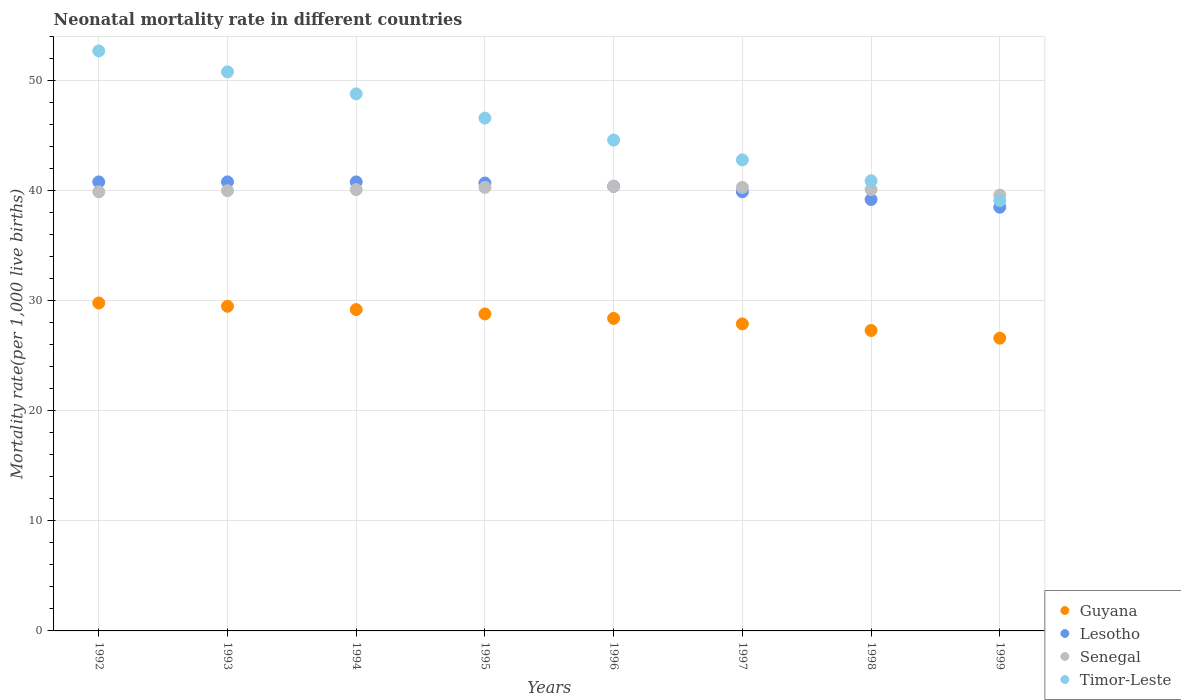How many different coloured dotlines are there?
Ensure brevity in your answer.  4. Is the number of dotlines equal to the number of legend labels?
Ensure brevity in your answer.  Yes. What is the neonatal mortality rate in Lesotho in 1993?
Offer a very short reply. 40.8. Across all years, what is the maximum neonatal mortality rate in Lesotho?
Your response must be concise. 40.8. Across all years, what is the minimum neonatal mortality rate in Guyana?
Make the answer very short. 26.6. In which year was the neonatal mortality rate in Lesotho minimum?
Keep it short and to the point. 1999. What is the total neonatal mortality rate in Lesotho in the graph?
Provide a succinct answer. 321.1. What is the difference between the neonatal mortality rate in Timor-Leste in 1996 and that in 1999?
Ensure brevity in your answer.  5.5. What is the difference between the neonatal mortality rate in Lesotho in 1995 and the neonatal mortality rate in Timor-Leste in 1996?
Keep it short and to the point. -3.9. What is the average neonatal mortality rate in Senegal per year?
Make the answer very short. 40.09. In the year 1995, what is the difference between the neonatal mortality rate in Timor-Leste and neonatal mortality rate in Lesotho?
Offer a very short reply. 5.9. In how many years, is the neonatal mortality rate in Timor-Leste greater than 44?
Your answer should be compact. 5. What is the ratio of the neonatal mortality rate in Guyana in 1993 to that in 1999?
Offer a very short reply. 1.11. Is the difference between the neonatal mortality rate in Timor-Leste in 1994 and 1995 greater than the difference between the neonatal mortality rate in Lesotho in 1994 and 1995?
Offer a terse response. Yes. What is the difference between the highest and the second highest neonatal mortality rate in Senegal?
Provide a succinct answer. 0.1. What is the difference between the highest and the lowest neonatal mortality rate in Timor-Leste?
Keep it short and to the point. 13.6. Is the sum of the neonatal mortality rate in Lesotho in 1993 and 1994 greater than the maximum neonatal mortality rate in Guyana across all years?
Offer a terse response. Yes. Is it the case that in every year, the sum of the neonatal mortality rate in Lesotho and neonatal mortality rate in Guyana  is greater than the neonatal mortality rate in Timor-Leste?
Keep it short and to the point. Yes. Does the neonatal mortality rate in Timor-Leste monotonically increase over the years?
Your answer should be very brief. No. Is the neonatal mortality rate in Timor-Leste strictly less than the neonatal mortality rate in Guyana over the years?
Your answer should be very brief. No. How many dotlines are there?
Keep it short and to the point. 4. How many years are there in the graph?
Keep it short and to the point. 8. What is the difference between two consecutive major ticks on the Y-axis?
Provide a short and direct response. 10. Are the values on the major ticks of Y-axis written in scientific E-notation?
Your response must be concise. No. Does the graph contain any zero values?
Your answer should be compact. No. What is the title of the graph?
Keep it short and to the point. Neonatal mortality rate in different countries. Does "San Marino" appear as one of the legend labels in the graph?
Provide a short and direct response. No. What is the label or title of the X-axis?
Your answer should be very brief. Years. What is the label or title of the Y-axis?
Offer a terse response. Mortality rate(per 1,0 live births). What is the Mortality rate(per 1,000 live births) in Guyana in 1992?
Your answer should be compact. 29.8. What is the Mortality rate(per 1,000 live births) of Lesotho in 1992?
Your response must be concise. 40.8. What is the Mortality rate(per 1,000 live births) in Senegal in 1992?
Provide a succinct answer. 39.9. What is the Mortality rate(per 1,000 live births) of Timor-Leste in 1992?
Offer a very short reply. 52.7. What is the Mortality rate(per 1,000 live births) in Guyana in 1993?
Give a very brief answer. 29.5. What is the Mortality rate(per 1,000 live births) of Lesotho in 1993?
Your response must be concise. 40.8. What is the Mortality rate(per 1,000 live births) in Senegal in 1993?
Your answer should be compact. 40. What is the Mortality rate(per 1,000 live births) in Timor-Leste in 1993?
Provide a short and direct response. 50.8. What is the Mortality rate(per 1,000 live births) in Guyana in 1994?
Offer a very short reply. 29.2. What is the Mortality rate(per 1,000 live births) in Lesotho in 1994?
Your answer should be compact. 40.8. What is the Mortality rate(per 1,000 live births) of Senegal in 1994?
Offer a terse response. 40.1. What is the Mortality rate(per 1,000 live births) in Timor-Leste in 1994?
Provide a succinct answer. 48.8. What is the Mortality rate(per 1,000 live births) in Guyana in 1995?
Offer a terse response. 28.8. What is the Mortality rate(per 1,000 live births) in Lesotho in 1995?
Offer a very short reply. 40.7. What is the Mortality rate(per 1,000 live births) of Senegal in 1995?
Your answer should be very brief. 40.3. What is the Mortality rate(per 1,000 live births) of Timor-Leste in 1995?
Offer a terse response. 46.6. What is the Mortality rate(per 1,000 live births) of Guyana in 1996?
Provide a short and direct response. 28.4. What is the Mortality rate(per 1,000 live births) in Lesotho in 1996?
Keep it short and to the point. 40.4. What is the Mortality rate(per 1,000 live births) in Senegal in 1996?
Offer a very short reply. 40.4. What is the Mortality rate(per 1,000 live births) of Timor-Leste in 1996?
Give a very brief answer. 44.6. What is the Mortality rate(per 1,000 live births) in Guyana in 1997?
Give a very brief answer. 27.9. What is the Mortality rate(per 1,000 live births) in Lesotho in 1997?
Your answer should be very brief. 39.9. What is the Mortality rate(per 1,000 live births) in Senegal in 1997?
Keep it short and to the point. 40.3. What is the Mortality rate(per 1,000 live births) of Timor-Leste in 1997?
Your response must be concise. 42.8. What is the Mortality rate(per 1,000 live births) in Guyana in 1998?
Your answer should be compact. 27.3. What is the Mortality rate(per 1,000 live births) in Lesotho in 1998?
Provide a short and direct response. 39.2. What is the Mortality rate(per 1,000 live births) of Senegal in 1998?
Offer a terse response. 40.1. What is the Mortality rate(per 1,000 live births) of Timor-Leste in 1998?
Ensure brevity in your answer.  40.9. What is the Mortality rate(per 1,000 live births) of Guyana in 1999?
Make the answer very short. 26.6. What is the Mortality rate(per 1,000 live births) in Lesotho in 1999?
Your answer should be compact. 38.5. What is the Mortality rate(per 1,000 live births) in Senegal in 1999?
Your response must be concise. 39.6. What is the Mortality rate(per 1,000 live births) of Timor-Leste in 1999?
Your answer should be compact. 39.1. Across all years, what is the maximum Mortality rate(per 1,000 live births) in Guyana?
Provide a short and direct response. 29.8. Across all years, what is the maximum Mortality rate(per 1,000 live births) of Lesotho?
Your answer should be very brief. 40.8. Across all years, what is the maximum Mortality rate(per 1,000 live births) of Senegal?
Ensure brevity in your answer.  40.4. Across all years, what is the maximum Mortality rate(per 1,000 live births) in Timor-Leste?
Give a very brief answer. 52.7. Across all years, what is the minimum Mortality rate(per 1,000 live births) in Guyana?
Your answer should be compact. 26.6. Across all years, what is the minimum Mortality rate(per 1,000 live births) of Lesotho?
Provide a short and direct response. 38.5. Across all years, what is the minimum Mortality rate(per 1,000 live births) of Senegal?
Provide a short and direct response. 39.6. Across all years, what is the minimum Mortality rate(per 1,000 live births) in Timor-Leste?
Offer a very short reply. 39.1. What is the total Mortality rate(per 1,000 live births) of Guyana in the graph?
Offer a very short reply. 227.5. What is the total Mortality rate(per 1,000 live births) in Lesotho in the graph?
Ensure brevity in your answer.  321.1. What is the total Mortality rate(per 1,000 live births) in Senegal in the graph?
Your response must be concise. 320.7. What is the total Mortality rate(per 1,000 live births) in Timor-Leste in the graph?
Keep it short and to the point. 366.3. What is the difference between the Mortality rate(per 1,000 live births) of Guyana in 1992 and that in 1993?
Your response must be concise. 0.3. What is the difference between the Mortality rate(per 1,000 live births) in Timor-Leste in 1992 and that in 1993?
Provide a succinct answer. 1.9. What is the difference between the Mortality rate(per 1,000 live births) of Lesotho in 1992 and that in 1994?
Offer a very short reply. 0. What is the difference between the Mortality rate(per 1,000 live births) in Senegal in 1992 and that in 1994?
Make the answer very short. -0.2. What is the difference between the Mortality rate(per 1,000 live births) in Timor-Leste in 1992 and that in 1994?
Offer a very short reply. 3.9. What is the difference between the Mortality rate(per 1,000 live births) of Lesotho in 1992 and that in 1995?
Provide a succinct answer. 0.1. What is the difference between the Mortality rate(per 1,000 live births) of Timor-Leste in 1992 and that in 1995?
Keep it short and to the point. 6.1. What is the difference between the Mortality rate(per 1,000 live births) of Guyana in 1992 and that in 1996?
Your answer should be very brief. 1.4. What is the difference between the Mortality rate(per 1,000 live births) of Senegal in 1992 and that in 1996?
Offer a very short reply. -0.5. What is the difference between the Mortality rate(per 1,000 live births) of Timor-Leste in 1992 and that in 1996?
Your answer should be very brief. 8.1. What is the difference between the Mortality rate(per 1,000 live births) of Lesotho in 1992 and that in 1997?
Provide a succinct answer. 0.9. What is the difference between the Mortality rate(per 1,000 live births) in Senegal in 1992 and that in 1997?
Ensure brevity in your answer.  -0.4. What is the difference between the Mortality rate(per 1,000 live births) of Guyana in 1992 and that in 1999?
Your response must be concise. 3.2. What is the difference between the Mortality rate(per 1,000 live births) in Lesotho in 1992 and that in 1999?
Keep it short and to the point. 2.3. What is the difference between the Mortality rate(per 1,000 live births) in Senegal in 1992 and that in 1999?
Your answer should be very brief. 0.3. What is the difference between the Mortality rate(per 1,000 live births) in Guyana in 1993 and that in 1994?
Offer a terse response. 0.3. What is the difference between the Mortality rate(per 1,000 live births) in Timor-Leste in 1993 and that in 1994?
Offer a very short reply. 2. What is the difference between the Mortality rate(per 1,000 live births) in Lesotho in 1993 and that in 1995?
Offer a terse response. 0.1. What is the difference between the Mortality rate(per 1,000 live births) of Senegal in 1993 and that in 1995?
Offer a terse response. -0.3. What is the difference between the Mortality rate(per 1,000 live births) of Timor-Leste in 1993 and that in 1995?
Offer a terse response. 4.2. What is the difference between the Mortality rate(per 1,000 live births) of Guyana in 1993 and that in 1996?
Give a very brief answer. 1.1. What is the difference between the Mortality rate(per 1,000 live births) of Lesotho in 1993 and that in 1996?
Provide a succinct answer. 0.4. What is the difference between the Mortality rate(per 1,000 live births) of Guyana in 1993 and that in 1997?
Offer a very short reply. 1.6. What is the difference between the Mortality rate(per 1,000 live births) of Lesotho in 1993 and that in 1998?
Ensure brevity in your answer.  1.6. What is the difference between the Mortality rate(per 1,000 live births) of Timor-Leste in 1993 and that in 1998?
Offer a very short reply. 9.9. What is the difference between the Mortality rate(per 1,000 live births) of Lesotho in 1993 and that in 1999?
Give a very brief answer. 2.3. What is the difference between the Mortality rate(per 1,000 live births) of Senegal in 1993 and that in 1999?
Offer a terse response. 0.4. What is the difference between the Mortality rate(per 1,000 live births) in Senegal in 1994 and that in 1995?
Make the answer very short. -0.2. What is the difference between the Mortality rate(per 1,000 live births) of Senegal in 1994 and that in 1996?
Provide a short and direct response. -0.3. What is the difference between the Mortality rate(per 1,000 live births) in Timor-Leste in 1994 and that in 1996?
Give a very brief answer. 4.2. What is the difference between the Mortality rate(per 1,000 live births) of Lesotho in 1994 and that in 1997?
Ensure brevity in your answer.  0.9. What is the difference between the Mortality rate(per 1,000 live births) of Senegal in 1994 and that in 1997?
Your answer should be compact. -0.2. What is the difference between the Mortality rate(per 1,000 live births) in Guyana in 1994 and that in 1998?
Your answer should be very brief. 1.9. What is the difference between the Mortality rate(per 1,000 live births) of Lesotho in 1994 and that in 1998?
Provide a short and direct response. 1.6. What is the difference between the Mortality rate(per 1,000 live births) of Timor-Leste in 1994 and that in 1998?
Provide a short and direct response. 7.9. What is the difference between the Mortality rate(per 1,000 live births) of Senegal in 1994 and that in 1999?
Ensure brevity in your answer.  0.5. What is the difference between the Mortality rate(per 1,000 live births) of Timor-Leste in 1994 and that in 1999?
Offer a terse response. 9.7. What is the difference between the Mortality rate(per 1,000 live births) of Guyana in 1995 and that in 1996?
Give a very brief answer. 0.4. What is the difference between the Mortality rate(per 1,000 live births) in Lesotho in 1995 and that in 1996?
Keep it short and to the point. 0.3. What is the difference between the Mortality rate(per 1,000 live births) in Timor-Leste in 1995 and that in 1997?
Your answer should be compact. 3.8. What is the difference between the Mortality rate(per 1,000 live births) of Guyana in 1995 and that in 1999?
Give a very brief answer. 2.2. What is the difference between the Mortality rate(per 1,000 live births) in Lesotho in 1995 and that in 1999?
Provide a short and direct response. 2.2. What is the difference between the Mortality rate(per 1,000 live births) of Timor-Leste in 1995 and that in 1999?
Your answer should be compact. 7.5. What is the difference between the Mortality rate(per 1,000 live births) in Senegal in 1996 and that in 1997?
Give a very brief answer. 0.1. What is the difference between the Mortality rate(per 1,000 live births) in Timor-Leste in 1996 and that in 1997?
Provide a short and direct response. 1.8. What is the difference between the Mortality rate(per 1,000 live births) of Guyana in 1996 and that in 1998?
Offer a very short reply. 1.1. What is the difference between the Mortality rate(per 1,000 live births) in Lesotho in 1996 and that in 1998?
Offer a terse response. 1.2. What is the difference between the Mortality rate(per 1,000 live births) in Senegal in 1996 and that in 1998?
Keep it short and to the point. 0.3. What is the difference between the Mortality rate(per 1,000 live births) in Guyana in 1996 and that in 1999?
Ensure brevity in your answer.  1.8. What is the difference between the Mortality rate(per 1,000 live births) in Lesotho in 1996 and that in 1999?
Keep it short and to the point. 1.9. What is the difference between the Mortality rate(per 1,000 live births) of Senegal in 1996 and that in 1999?
Your answer should be compact. 0.8. What is the difference between the Mortality rate(per 1,000 live births) in Timor-Leste in 1996 and that in 1999?
Keep it short and to the point. 5.5. What is the difference between the Mortality rate(per 1,000 live births) of Lesotho in 1997 and that in 1998?
Give a very brief answer. 0.7. What is the difference between the Mortality rate(per 1,000 live births) in Senegal in 1997 and that in 1998?
Keep it short and to the point. 0.2. What is the difference between the Mortality rate(per 1,000 live births) of Timor-Leste in 1997 and that in 1998?
Your response must be concise. 1.9. What is the difference between the Mortality rate(per 1,000 live births) of Lesotho in 1997 and that in 1999?
Your answer should be compact. 1.4. What is the difference between the Mortality rate(per 1,000 live births) in Timor-Leste in 1997 and that in 1999?
Your response must be concise. 3.7. What is the difference between the Mortality rate(per 1,000 live births) in Lesotho in 1998 and that in 1999?
Your response must be concise. 0.7. What is the difference between the Mortality rate(per 1,000 live births) in Senegal in 1998 and that in 1999?
Give a very brief answer. 0.5. What is the difference between the Mortality rate(per 1,000 live births) in Guyana in 1992 and the Mortality rate(per 1,000 live births) in Timor-Leste in 1993?
Give a very brief answer. -21. What is the difference between the Mortality rate(per 1,000 live births) of Lesotho in 1992 and the Mortality rate(per 1,000 live births) of Timor-Leste in 1993?
Make the answer very short. -10. What is the difference between the Mortality rate(per 1,000 live births) of Senegal in 1992 and the Mortality rate(per 1,000 live births) of Timor-Leste in 1993?
Offer a very short reply. -10.9. What is the difference between the Mortality rate(per 1,000 live births) in Guyana in 1992 and the Mortality rate(per 1,000 live births) in Senegal in 1994?
Offer a terse response. -10.3. What is the difference between the Mortality rate(per 1,000 live births) in Senegal in 1992 and the Mortality rate(per 1,000 live births) in Timor-Leste in 1994?
Provide a succinct answer. -8.9. What is the difference between the Mortality rate(per 1,000 live births) in Guyana in 1992 and the Mortality rate(per 1,000 live births) in Timor-Leste in 1995?
Offer a terse response. -16.8. What is the difference between the Mortality rate(per 1,000 live births) of Senegal in 1992 and the Mortality rate(per 1,000 live births) of Timor-Leste in 1995?
Ensure brevity in your answer.  -6.7. What is the difference between the Mortality rate(per 1,000 live births) in Guyana in 1992 and the Mortality rate(per 1,000 live births) in Lesotho in 1996?
Provide a succinct answer. -10.6. What is the difference between the Mortality rate(per 1,000 live births) in Guyana in 1992 and the Mortality rate(per 1,000 live births) in Timor-Leste in 1996?
Provide a succinct answer. -14.8. What is the difference between the Mortality rate(per 1,000 live births) of Lesotho in 1992 and the Mortality rate(per 1,000 live births) of Senegal in 1996?
Provide a short and direct response. 0.4. What is the difference between the Mortality rate(per 1,000 live births) of Lesotho in 1992 and the Mortality rate(per 1,000 live births) of Timor-Leste in 1996?
Your answer should be compact. -3.8. What is the difference between the Mortality rate(per 1,000 live births) in Senegal in 1992 and the Mortality rate(per 1,000 live births) in Timor-Leste in 1996?
Offer a very short reply. -4.7. What is the difference between the Mortality rate(per 1,000 live births) of Guyana in 1992 and the Mortality rate(per 1,000 live births) of Senegal in 1997?
Your answer should be compact. -10.5. What is the difference between the Mortality rate(per 1,000 live births) of Guyana in 1992 and the Mortality rate(per 1,000 live births) of Timor-Leste in 1997?
Your answer should be compact. -13. What is the difference between the Mortality rate(per 1,000 live births) in Guyana in 1992 and the Mortality rate(per 1,000 live births) in Lesotho in 1998?
Give a very brief answer. -9.4. What is the difference between the Mortality rate(per 1,000 live births) of Lesotho in 1992 and the Mortality rate(per 1,000 live births) of Timor-Leste in 1998?
Keep it short and to the point. -0.1. What is the difference between the Mortality rate(per 1,000 live births) of Senegal in 1992 and the Mortality rate(per 1,000 live births) of Timor-Leste in 1998?
Provide a short and direct response. -1. What is the difference between the Mortality rate(per 1,000 live births) of Guyana in 1992 and the Mortality rate(per 1,000 live births) of Senegal in 1999?
Your response must be concise. -9.8. What is the difference between the Mortality rate(per 1,000 live births) of Guyana in 1992 and the Mortality rate(per 1,000 live births) of Timor-Leste in 1999?
Your answer should be compact. -9.3. What is the difference between the Mortality rate(per 1,000 live births) in Lesotho in 1992 and the Mortality rate(per 1,000 live births) in Senegal in 1999?
Keep it short and to the point. 1.2. What is the difference between the Mortality rate(per 1,000 live births) of Guyana in 1993 and the Mortality rate(per 1,000 live births) of Lesotho in 1994?
Your response must be concise. -11.3. What is the difference between the Mortality rate(per 1,000 live births) in Guyana in 1993 and the Mortality rate(per 1,000 live births) in Timor-Leste in 1994?
Keep it short and to the point. -19.3. What is the difference between the Mortality rate(per 1,000 live births) in Lesotho in 1993 and the Mortality rate(per 1,000 live births) in Senegal in 1994?
Your answer should be compact. 0.7. What is the difference between the Mortality rate(per 1,000 live births) of Guyana in 1993 and the Mortality rate(per 1,000 live births) of Lesotho in 1995?
Give a very brief answer. -11.2. What is the difference between the Mortality rate(per 1,000 live births) of Guyana in 1993 and the Mortality rate(per 1,000 live births) of Senegal in 1995?
Ensure brevity in your answer.  -10.8. What is the difference between the Mortality rate(per 1,000 live births) in Guyana in 1993 and the Mortality rate(per 1,000 live births) in Timor-Leste in 1995?
Offer a very short reply. -17.1. What is the difference between the Mortality rate(per 1,000 live births) in Lesotho in 1993 and the Mortality rate(per 1,000 live births) in Timor-Leste in 1995?
Your answer should be compact. -5.8. What is the difference between the Mortality rate(per 1,000 live births) of Senegal in 1993 and the Mortality rate(per 1,000 live births) of Timor-Leste in 1995?
Your answer should be very brief. -6.6. What is the difference between the Mortality rate(per 1,000 live births) in Guyana in 1993 and the Mortality rate(per 1,000 live births) in Lesotho in 1996?
Your response must be concise. -10.9. What is the difference between the Mortality rate(per 1,000 live births) in Guyana in 1993 and the Mortality rate(per 1,000 live births) in Timor-Leste in 1996?
Your response must be concise. -15.1. What is the difference between the Mortality rate(per 1,000 live births) in Lesotho in 1993 and the Mortality rate(per 1,000 live births) in Senegal in 1996?
Give a very brief answer. 0.4. What is the difference between the Mortality rate(per 1,000 live births) in Guyana in 1993 and the Mortality rate(per 1,000 live births) in Lesotho in 1997?
Your answer should be compact. -10.4. What is the difference between the Mortality rate(per 1,000 live births) in Guyana in 1993 and the Mortality rate(per 1,000 live births) in Senegal in 1997?
Your answer should be very brief. -10.8. What is the difference between the Mortality rate(per 1,000 live births) in Guyana in 1993 and the Mortality rate(per 1,000 live births) in Timor-Leste in 1997?
Give a very brief answer. -13.3. What is the difference between the Mortality rate(per 1,000 live births) of Senegal in 1993 and the Mortality rate(per 1,000 live births) of Timor-Leste in 1997?
Offer a very short reply. -2.8. What is the difference between the Mortality rate(per 1,000 live births) of Guyana in 1993 and the Mortality rate(per 1,000 live births) of Lesotho in 1998?
Ensure brevity in your answer.  -9.7. What is the difference between the Mortality rate(per 1,000 live births) of Guyana in 1993 and the Mortality rate(per 1,000 live births) of Timor-Leste in 1998?
Offer a terse response. -11.4. What is the difference between the Mortality rate(per 1,000 live births) in Lesotho in 1993 and the Mortality rate(per 1,000 live births) in Timor-Leste in 1998?
Keep it short and to the point. -0.1. What is the difference between the Mortality rate(per 1,000 live births) of Senegal in 1993 and the Mortality rate(per 1,000 live births) of Timor-Leste in 1998?
Provide a short and direct response. -0.9. What is the difference between the Mortality rate(per 1,000 live births) of Guyana in 1993 and the Mortality rate(per 1,000 live births) of Lesotho in 1999?
Ensure brevity in your answer.  -9. What is the difference between the Mortality rate(per 1,000 live births) of Guyana in 1993 and the Mortality rate(per 1,000 live births) of Senegal in 1999?
Offer a very short reply. -10.1. What is the difference between the Mortality rate(per 1,000 live births) in Guyana in 1993 and the Mortality rate(per 1,000 live births) in Timor-Leste in 1999?
Your answer should be compact. -9.6. What is the difference between the Mortality rate(per 1,000 live births) in Lesotho in 1993 and the Mortality rate(per 1,000 live births) in Senegal in 1999?
Your answer should be compact. 1.2. What is the difference between the Mortality rate(per 1,000 live births) of Lesotho in 1993 and the Mortality rate(per 1,000 live births) of Timor-Leste in 1999?
Give a very brief answer. 1.7. What is the difference between the Mortality rate(per 1,000 live births) of Senegal in 1993 and the Mortality rate(per 1,000 live births) of Timor-Leste in 1999?
Your answer should be compact. 0.9. What is the difference between the Mortality rate(per 1,000 live births) of Guyana in 1994 and the Mortality rate(per 1,000 live births) of Timor-Leste in 1995?
Provide a succinct answer. -17.4. What is the difference between the Mortality rate(per 1,000 live births) in Lesotho in 1994 and the Mortality rate(per 1,000 live births) in Senegal in 1995?
Your answer should be compact. 0.5. What is the difference between the Mortality rate(per 1,000 live births) in Guyana in 1994 and the Mortality rate(per 1,000 live births) in Lesotho in 1996?
Your response must be concise. -11.2. What is the difference between the Mortality rate(per 1,000 live births) in Guyana in 1994 and the Mortality rate(per 1,000 live births) in Timor-Leste in 1996?
Ensure brevity in your answer.  -15.4. What is the difference between the Mortality rate(per 1,000 live births) of Lesotho in 1994 and the Mortality rate(per 1,000 live births) of Senegal in 1996?
Make the answer very short. 0.4. What is the difference between the Mortality rate(per 1,000 live births) in Senegal in 1994 and the Mortality rate(per 1,000 live births) in Timor-Leste in 1996?
Your response must be concise. -4.5. What is the difference between the Mortality rate(per 1,000 live births) in Guyana in 1994 and the Mortality rate(per 1,000 live births) in Lesotho in 1998?
Offer a very short reply. -10. What is the difference between the Mortality rate(per 1,000 live births) in Guyana in 1994 and the Mortality rate(per 1,000 live births) in Senegal in 1998?
Your answer should be very brief. -10.9. What is the difference between the Mortality rate(per 1,000 live births) in Lesotho in 1994 and the Mortality rate(per 1,000 live births) in Senegal in 1998?
Offer a very short reply. 0.7. What is the difference between the Mortality rate(per 1,000 live births) of Guyana in 1994 and the Mortality rate(per 1,000 live births) of Senegal in 1999?
Give a very brief answer. -10.4. What is the difference between the Mortality rate(per 1,000 live births) of Guyana in 1994 and the Mortality rate(per 1,000 live births) of Timor-Leste in 1999?
Keep it short and to the point. -9.9. What is the difference between the Mortality rate(per 1,000 live births) in Lesotho in 1994 and the Mortality rate(per 1,000 live births) in Senegal in 1999?
Your answer should be very brief. 1.2. What is the difference between the Mortality rate(per 1,000 live births) of Lesotho in 1994 and the Mortality rate(per 1,000 live births) of Timor-Leste in 1999?
Your answer should be very brief. 1.7. What is the difference between the Mortality rate(per 1,000 live births) in Senegal in 1994 and the Mortality rate(per 1,000 live births) in Timor-Leste in 1999?
Offer a very short reply. 1. What is the difference between the Mortality rate(per 1,000 live births) in Guyana in 1995 and the Mortality rate(per 1,000 live births) in Timor-Leste in 1996?
Give a very brief answer. -15.8. What is the difference between the Mortality rate(per 1,000 live births) in Lesotho in 1995 and the Mortality rate(per 1,000 live births) in Timor-Leste in 1996?
Offer a terse response. -3.9. What is the difference between the Mortality rate(per 1,000 live births) of Senegal in 1995 and the Mortality rate(per 1,000 live births) of Timor-Leste in 1996?
Your answer should be very brief. -4.3. What is the difference between the Mortality rate(per 1,000 live births) in Guyana in 1995 and the Mortality rate(per 1,000 live births) in Lesotho in 1997?
Your answer should be very brief. -11.1. What is the difference between the Mortality rate(per 1,000 live births) in Guyana in 1995 and the Mortality rate(per 1,000 live births) in Timor-Leste in 1997?
Give a very brief answer. -14. What is the difference between the Mortality rate(per 1,000 live births) of Lesotho in 1995 and the Mortality rate(per 1,000 live births) of Senegal in 1997?
Provide a short and direct response. 0.4. What is the difference between the Mortality rate(per 1,000 live births) of Lesotho in 1995 and the Mortality rate(per 1,000 live births) of Timor-Leste in 1997?
Your answer should be compact. -2.1. What is the difference between the Mortality rate(per 1,000 live births) of Guyana in 1995 and the Mortality rate(per 1,000 live births) of Senegal in 1998?
Ensure brevity in your answer.  -11.3. What is the difference between the Mortality rate(per 1,000 live births) in Guyana in 1995 and the Mortality rate(per 1,000 live births) in Senegal in 1999?
Make the answer very short. -10.8. What is the difference between the Mortality rate(per 1,000 live births) of Lesotho in 1995 and the Mortality rate(per 1,000 live births) of Timor-Leste in 1999?
Ensure brevity in your answer.  1.6. What is the difference between the Mortality rate(per 1,000 live births) in Guyana in 1996 and the Mortality rate(per 1,000 live births) in Lesotho in 1997?
Your answer should be compact. -11.5. What is the difference between the Mortality rate(per 1,000 live births) of Guyana in 1996 and the Mortality rate(per 1,000 live births) of Senegal in 1997?
Ensure brevity in your answer.  -11.9. What is the difference between the Mortality rate(per 1,000 live births) in Guyana in 1996 and the Mortality rate(per 1,000 live births) in Timor-Leste in 1997?
Give a very brief answer. -14.4. What is the difference between the Mortality rate(per 1,000 live births) of Lesotho in 1996 and the Mortality rate(per 1,000 live births) of Senegal in 1997?
Provide a succinct answer. 0.1. What is the difference between the Mortality rate(per 1,000 live births) in Lesotho in 1996 and the Mortality rate(per 1,000 live births) in Timor-Leste in 1997?
Provide a succinct answer. -2.4. What is the difference between the Mortality rate(per 1,000 live births) in Senegal in 1996 and the Mortality rate(per 1,000 live births) in Timor-Leste in 1997?
Your answer should be compact. -2.4. What is the difference between the Mortality rate(per 1,000 live births) in Guyana in 1996 and the Mortality rate(per 1,000 live births) in Senegal in 1998?
Your answer should be compact. -11.7. What is the difference between the Mortality rate(per 1,000 live births) of Lesotho in 1996 and the Mortality rate(per 1,000 live births) of Senegal in 1998?
Offer a terse response. 0.3. What is the difference between the Mortality rate(per 1,000 live births) in Lesotho in 1996 and the Mortality rate(per 1,000 live births) in Timor-Leste in 1998?
Keep it short and to the point. -0.5. What is the difference between the Mortality rate(per 1,000 live births) of Lesotho in 1996 and the Mortality rate(per 1,000 live births) of Senegal in 1999?
Your response must be concise. 0.8. What is the difference between the Mortality rate(per 1,000 live births) in Lesotho in 1996 and the Mortality rate(per 1,000 live births) in Timor-Leste in 1999?
Give a very brief answer. 1.3. What is the difference between the Mortality rate(per 1,000 live births) in Guyana in 1997 and the Mortality rate(per 1,000 live births) in Lesotho in 1998?
Your answer should be very brief. -11.3. What is the difference between the Mortality rate(per 1,000 live births) in Guyana in 1997 and the Mortality rate(per 1,000 live births) in Timor-Leste in 1998?
Your answer should be very brief. -13. What is the difference between the Mortality rate(per 1,000 live births) in Lesotho in 1997 and the Mortality rate(per 1,000 live births) in Senegal in 1998?
Your answer should be very brief. -0.2. What is the difference between the Mortality rate(per 1,000 live births) of Senegal in 1997 and the Mortality rate(per 1,000 live births) of Timor-Leste in 1998?
Ensure brevity in your answer.  -0.6. What is the difference between the Mortality rate(per 1,000 live births) in Guyana in 1997 and the Mortality rate(per 1,000 live births) in Senegal in 1999?
Give a very brief answer. -11.7. What is the difference between the Mortality rate(per 1,000 live births) in Guyana in 1997 and the Mortality rate(per 1,000 live births) in Timor-Leste in 1999?
Provide a short and direct response. -11.2. What is the difference between the Mortality rate(per 1,000 live births) in Lesotho in 1997 and the Mortality rate(per 1,000 live births) in Senegal in 1999?
Provide a short and direct response. 0.3. What is the difference between the Mortality rate(per 1,000 live births) in Lesotho in 1997 and the Mortality rate(per 1,000 live births) in Timor-Leste in 1999?
Make the answer very short. 0.8. What is the difference between the Mortality rate(per 1,000 live births) in Guyana in 1998 and the Mortality rate(per 1,000 live births) in Lesotho in 1999?
Keep it short and to the point. -11.2. What is the difference between the Mortality rate(per 1,000 live births) in Guyana in 1998 and the Mortality rate(per 1,000 live births) in Timor-Leste in 1999?
Offer a very short reply. -11.8. What is the difference between the Mortality rate(per 1,000 live births) of Lesotho in 1998 and the Mortality rate(per 1,000 live births) of Senegal in 1999?
Give a very brief answer. -0.4. What is the difference between the Mortality rate(per 1,000 live births) in Lesotho in 1998 and the Mortality rate(per 1,000 live births) in Timor-Leste in 1999?
Your answer should be compact. 0.1. What is the difference between the Mortality rate(per 1,000 live births) of Senegal in 1998 and the Mortality rate(per 1,000 live births) of Timor-Leste in 1999?
Your response must be concise. 1. What is the average Mortality rate(per 1,000 live births) of Guyana per year?
Keep it short and to the point. 28.44. What is the average Mortality rate(per 1,000 live births) in Lesotho per year?
Your answer should be very brief. 40.14. What is the average Mortality rate(per 1,000 live births) in Senegal per year?
Provide a succinct answer. 40.09. What is the average Mortality rate(per 1,000 live births) in Timor-Leste per year?
Keep it short and to the point. 45.79. In the year 1992, what is the difference between the Mortality rate(per 1,000 live births) in Guyana and Mortality rate(per 1,000 live births) in Timor-Leste?
Offer a terse response. -22.9. In the year 1992, what is the difference between the Mortality rate(per 1,000 live births) of Lesotho and Mortality rate(per 1,000 live births) of Senegal?
Give a very brief answer. 0.9. In the year 1992, what is the difference between the Mortality rate(per 1,000 live births) in Lesotho and Mortality rate(per 1,000 live births) in Timor-Leste?
Keep it short and to the point. -11.9. In the year 1993, what is the difference between the Mortality rate(per 1,000 live births) of Guyana and Mortality rate(per 1,000 live births) of Timor-Leste?
Offer a terse response. -21.3. In the year 1993, what is the difference between the Mortality rate(per 1,000 live births) in Lesotho and Mortality rate(per 1,000 live births) in Senegal?
Your answer should be very brief. 0.8. In the year 1993, what is the difference between the Mortality rate(per 1,000 live births) in Lesotho and Mortality rate(per 1,000 live births) in Timor-Leste?
Make the answer very short. -10. In the year 1993, what is the difference between the Mortality rate(per 1,000 live births) of Senegal and Mortality rate(per 1,000 live births) of Timor-Leste?
Provide a succinct answer. -10.8. In the year 1994, what is the difference between the Mortality rate(per 1,000 live births) of Guyana and Mortality rate(per 1,000 live births) of Lesotho?
Keep it short and to the point. -11.6. In the year 1994, what is the difference between the Mortality rate(per 1,000 live births) in Guyana and Mortality rate(per 1,000 live births) in Senegal?
Offer a very short reply. -10.9. In the year 1994, what is the difference between the Mortality rate(per 1,000 live births) in Guyana and Mortality rate(per 1,000 live births) in Timor-Leste?
Provide a short and direct response. -19.6. In the year 1994, what is the difference between the Mortality rate(per 1,000 live births) of Lesotho and Mortality rate(per 1,000 live births) of Timor-Leste?
Offer a terse response. -8. In the year 1995, what is the difference between the Mortality rate(per 1,000 live births) of Guyana and Mortality rate(per 1,000 live births) of Timor-Leste?
Offer a very short reply. -17.8. In the year 1995, what is the difference between the Mortality rate(per 1,000 live births) in Senegal and Mortality rate(per 1,000 live births) in Timor-Leste?
Provide a succinct answer. -6.3. In the year 1996, what is the difference between the Mortality rate(per 1,000 live births) of Guyana and Mortality rate(per 1,000 live births) of Senegal?
Provide a succinct answer. -12. In the year 1996, what is the difference between the Mortality rate(per 1,000 live births) in Guyana and Mortality rate(per 1,000 live births) in Timor-Leste?
Provide a short and direct response. -16.2. In the year 1996, what is the difference between the Mortality rate(per 1,000 live births) of Senegal and Mortality rate(per 1,000 live births) of Timor-Leste?
Your answer should be compact. -4.2. In the year 1997, what is the difference between the Mortality rate(per 1,000 live births) in Guyana and Mortality rate(per 1,000 live births) in Senegal?
Your answer should be very brief. -12.4. In the year 1997, what is the difference between the Mortality rate(per 1,000 live births) in Guyana and Mortality rate(per 1,000 live births) in Timor-Leste?
Give a very brief answer. -14.9. In the year 1997, what is the difference between the Mortality rate(per 1,000 live births) of Lesotho and Mortality rate(per 1,000 live births) of Senegal?
Your response must be concise. -0.4. In the year 1997, what is the difference between the Mortality rate(per 1,000 live births) in Senegal and Mortality rate(per 1,000 live births) in Timor-Leste?
Offer a terse response. -2.5. In the year 1998, what is the difference between the Mortality rate(per 1,000 live births) in Guyana and Mortality rate(per 1,000 live births) in Lesotho?
Ensure brevity in your answer.  -11.9. In the year 1998, what is the difference between the Mortality rate(per 1,000 live births) in Guyana and Mortality rate(per 1,000 live births) in Senegal?
Your answer should be very brief. -12.8. In the year 1998, what is the difference between the Mortality rate(per 1,000 live births) of Lesotho and Mortality rate(per 1,000 live births) of Senegal?
Offer a very short reply. -0.9. In the year 1999, what is the difference between the Mortality rate(per 1,000 live births) of Guyana and Mortality rate(per 1,000 live births) of Senegal?
Give a very brief answer. -13. In the year 1999, what is the difference between the Mortality rate(per 1,000 live births) in Lesotho and Mortality rate(per 1,000 live births) in Senegal?
Offer a terse response. -1.1. What is the ratio of the Mortality rate(per 1,000 live births) of Guyana in 1992 to that in 1993?
Provide a short and direct response. 1.01. What is the ratio of the Mortality rate(per 1,000 live births) in Timor-Leste in 1992 to that in 1993?
Provide a succinct answer. 1.04. What is the ratio of the Mortality rate(per 1,000 live births) in Guyana in 1992 to that in 1994?
Your answer should be compact. 1.02. What is the ratio of the Mortality rate(per 1,000 live births) in Lesotho in 1992 to that in 1994?
Ensure brevity in your answer.  1. What is the ratio of the Mortality rate(per 1,000 live births) of Senegal in 1992 to that in 1994?
Keep it short and to the point. 0.99. What is the ratio of the Mortality rate(per 1,000 live births) of Timor-Leste in 1992 to that in 1994?
Your answer should be compact. 1.08. What is the ratio of the Mortality rate(per 1,000 live births) of Guyana in 1992 to that in 1995?
Keep it short and to the point. 1.03. What is the ratio of the Mortality rate(per 1,000 live births) of Timor-Leste in 1992 to that in 1995?
Ensure brevity in your answer.  1.13. What is the ratio of the Mortality rate(per 1,000 live births) of Guyana in 1992 to that in 1996?
Keep it short and to the point. 1.05. What is the ratio of the Mortality rate(per 1,000 live births) of Lesotho in 1992 to that in 1996?
Provide a short and direct response. 1.01. What is the ratio of the Mortality rate(per 1,000 live births) of Senegal in 1992 to that in 1996?
Offer a terse response. 0.99. What is the ratio of the Mortality rate(per 1,000 live births) in Timor-Leste in 1992 to that in 1996?
Your response must be concise. 1.18. What is the ratio of the Mortality rate(per 1,000 live births) in Guyana in 1992 to that in 1997?
Make the answer very short. 1.07. What is the ratio of the Mortality rate(per 1,000 live births) of Lesotho in 1992 to that in 1997?
Give a very brief answer. 1.02. What is the ratio of the Mortality rate(per 1,000 live births) in Senegal in 1992 to that in 1997?
Your answer should be very brief. 0.99. What is the ratio of the Mortality rate(per 1,000 live births) in Timor-Leste in 1992 to that in 1997?
Provide a short and direct response. 1.23. What is the ratio of the Mortality rate(per 1,000 live births) in Guyana in 1992 to that in 1998?
Give a very brief answer. 1.09. What is the ratio of the Mortality rate(per 1,000 live births) of Lesotho in 1992 to that in 1998?
Your answer should be very brief. 1.04. What is the ratio of the Mortality rate(per 1,000 live births) of Timor-Leste in 1992 to that in 1998?
Your response must be concise. 1.29. What is the ratio of the Mortality rate(per 1,000 live births) of Guyana in 1992 to that in 1999?
Provide a short and direct response. 1.12. What is the ratio of the Mortality rate(per 1,000 live births) of Lesotho in 1992 to that in 1999?
Offer a terse response. 1.06. What is the ratio of the Mortality rate(per 1,000 live births) of Senegal in 1992 to that in 1999?
Your answer should be compact. 1.01. What is the ratio of the Mortality rate(per 1,000 live births) of Timor-Leste in 1992 to that in 1999?
Keep it short and to the point. 1.35. What is the ratio of the Mortality rate(per 1,000 live births) of Guyana in 1993 to that in 1994?
Give a very brief answer. 1.01. What is the ratio of the Mortality rate(per 1,000 live births) in Lesotho in 1993 to that in 1994?
Give a very brief answer. 1. What is the ratio of the Mortality rate(per 1,000 live births) in Timor-Leste in 1993 to that in 1994?
Offer a terse response. 1.04. What is the ratio of the Mortality rate(per 1,000 live births) of Guyana in 1993 to that in 1995?
Offer a terse response. 1.02. What is the ratio of the Mortality rate(per 1,000 live births) in Lesotho in 1993 to that in 1995?
Your answer should be compact. 1. What is the ratio of the Mortality rate(per 1,000 live births) in Senegal in 1993 to that in 1995?
Your answer should be very brief. 0.99. What is the ratio of the Mortality rate(per 1,000 live births) in Timor-Leste in 1993 to that in 1995?
Offer a terse response. 1.09. What is the ratio of the Mortality rate(per 1,000 live births) of Guyana in 1993 to that in 1996?
Give a very brief answer. 1.04. What is the ratio of the Mortality rate(per 1,000 live births) in Lesotho in 1993 to that in 1996?
Your answer should be very brief. 1.01. What is the ratio of the Mortality rate(per 1,000 live births) in Senegal in 1993 to that in 1996?
Provide a short and direct response. 0.99. What is the ratio of the Mortality rate(per 1,000 live births) in Timor-Leste in 1993 to that in 1996?
Keep it short and to the point. 1.14. What is the ratio of the Mortality rate(per 1,000 live births) of Guyana in 1993 to that in 1997?
Provide a succinct answer. 1.06. What is the ratio of the Mortality rate(per 1,000 live births) of Lesotho in 1993 to that in 1997?
Provide a succinct answer. 1.02. What is the ratio of the Mortality rate(per 1,000 live births) of Timor-Leste in 1993 to that in 1997?
Give a very brief answer. 1.19. What is the ratio of the Mortality rate(per 1,000 live births) in Guyana in 1993 to that in 1998?
Offer a terse response. 1.08. What is the ratio of the Mortality rate(per 1,000 live births) of Lesotho in 1993 to that in 1998?
Provide a short and direct response. 1.04. What is the ratio of the Mortality rate(per 1,000 live births) of Senegal in 1993 to that in 1998?
Your response must be concise. 1. What is the ratio of the Mortality rate(per 1,000 live births) of Timor-Leste in 1993 to that in 1998?
Your answer should be very brief. 1.24. What is the ratio of the Mortality rate(per 1,000 live births) in Guyana in 1993 to that in 1999?
Your answer should be very brief. 1.11. What is the ratio of the Mortality rate(per 1,000 live births) of Lesotho in 1993 to that in 1999?
Give a very brief answer. 1.06. What is the ratio of the Mortality rate(per 1,000 live births) of Timor-Leste in 1993 to that in 1999?
Keep it short and to the point. 1.3. What is the ratio of the Mortality rate(per 1,000 live births) of Guyana in 1994 to that in 1995?
Your answer should be very brief. 1.01. What is the ratio of the Mortality rate(per 1,000 live births) in Lesotho in 1994 to that in 1995?
Keep it short and to the point. 1. What is the ratio of the Mortality rate(per 1,000 live births) of Senegal in 1994 to that in 1995?
Ensure brevity in your answer.  0.99. What is the ratio of the Mortality rate(per 1,000 live births) in Timor-Leste in 1994 to that in 1995?
Offer a very short reply. 1.05. What is the ratio of the Mortality rate(per 1,000 live births) of Guyana in 1994 to that in 1996?
Your answer should be very brief. 1.03. What is the ratio of the Mortality rate(per 1,000 live births) in Lesotho in 1994 to that in 1996?
Ensure brevity in your answer.  1.01. What is the ratio of the Mortality rate(per 1,000 live births) of Timor-Leste in 1994 to that in 1996?
Provide a short and direct response. 1.09. What is the ratio of the Mortality rate(per 1,000 live births) of Guyana in 1994 to that in 1997?
Make the answer very short. 1.05. What is the ratio of the Mortality rate(per 1,000 live births) of Lesotho in 1994 to that in 1997?
Your answer should be compact. 1.02. What is the ratio of the Mortality rate(per 1,000 live births) in Timor-Leste in 1994 to that in 1997?
Give a very brief answer. 1.14. What is the ratio of the Mortality rate(per 1,000 live births) of Guyana in 1994 to that in 1998?
Ensure brevity in your answer.  1.07. What is the ratio of the Mortality rate(per 1,000 live births) of Lesotho in 1994 to that in 1998?
Your answer should be compact. 1.04. What is the ratio of the Mortality rate(per 1,000 live births) of Senegal in 1994 to that in 1998?
Your response must be concise. 1. What is the ratio of the Mortality rate(per 1,000 live births) in Timor-Leste in 1994 to that in 1998?
Your answer should be compact. 1.19. What is the ratio of the Mortality rate(per 1,000 live births) in Guyana in 1994 to that in 1999?
Ensure brevity in your answer.  1.1. What is the ratio of the Mortality rate(per 1,000 live births) of Lesotho in 1994 to that in 1999?
Provide a short and direct response. 1.06. What is the ratio of the Mortality rate(per 1,000 live births) in Senegal in 1994 to that in 1999?
Keep it short and to the point. 1.01. What is the ratio of the Mortality rate(per 1,000 live births) of Timor-Leste in 1994 to that in 1999?
Offer a terse response. 1.25. What is the ratio of the Mortality rate(per 1,000 live births) of Guyana in 1995 to that in 1996?
Provide a succinct answer. 1.01. What is the ratio of the Mortality rate(per 1,000 live births) in Lesotho in 1995 to that in 1996?
Ensure brevity in your answer.  1.01. What is the ratio of the Mortality rate(per 1,000 live births) in Senegal in 1995 to that in 1996?
Offer a very short reply. 1. What is the ratio of the Mortality rate(per 1,000 live births) in Timor-Leste in 1995 to that in 1996?
Give a very brief answer. 1.04. What is the ratio of the Mortality rate(per 1,000 live births) in Guyana in 1995 to that in 1997?
Offer a terse response. 1.03. What is the ratio of the Mortality rate(per 1,000 live births) in Lesotho in 1995 to that in 1997?
Make the answer very short. 1.02. What is the ratio of the Mortality rate(per 1,000 live births) in Timor-Leste in 1995 to that in 1997?
Make the answer very short. 1.09. What is the ratio of the Mortality rate(per 1,000 live births) of Guyana in 1995 to that in 1998?
Give a very brief answer. 1.05. What is the ratio of the Mortality rate(per 1,000 live births) in Lesotho in 1995 to that in 1998?
Your response must be concise. 1.04. What is the ratio of the Mortality rate(per 1,000 live births) of Senegal in 1995 to that in 1998?
Your answer should be very brief. 1. What is the ratio of the Mortality rate(per 1,000 live births) of Timor-Leste in 1995 to that in 1998?
Your answer should be compact. 1.14. What is the ratio of the Mortality rate(per 1,000 live births) of Guyana in 1995 to that in 1999?
Your answer should be compact. 1.08. What is the ratio of the Mortality rate(per 1,000 live births) of Lesotho in 1995 to that in 1999?
Offer a terse response. 1.06. What is the ratio of the Mortality rate(per 1,000 live births) of Senegal in 1995 to that in 1999?
Your answer should be compact. 1.02. What is the ratio of the Mortality rate(per 1,000 live births) in Timor-Leste in 1995 to that in 1999?
Your response must be concise. 1.19. What is the ratio of the Mortality rate(per 1,000 live births) of Guyana in 1996 to that in 1997?
Make the answer very short. 1.02. What is the ratio of the Mortality rate(per 1,000 live births) in Lesotho in 1996 to that in 1997?
Give a very brief answer. 1.01. What is the ratio of the Mortality rate(per 1,000 live births) of Timor-Leste in 1996 to that in 1997?
Offer a very short reply. 1.04. What is the ratio of the Mortality rate(per 1,000 live births) in Guyana in 1996 to that in 1998?
Give a very brief answer. 1.04. What is the ratio of the Mortality rate(per 1,000 live births) in Lesotho in 1996 to that in 1998?
Your answer should be compact. 1.03. What is the ratio of the Mortality rate(per 1,000 live births) in Senegal in 1996 to that in 1998?
Ensure brevity in your answer.  1.01. What is the ratio of the Mortality rate(per 1,000 live births) in Timor-Leste in 1996 to that in 1998?
Offer a terse response. 1.09. What is the ratio of the Mortality rate(per 1,000 live births) of Guyana in 1996 to that in 1999?
Your answer should be very brief. 1.07. What is the ratio of the Mortality rate(per 1,000 live births) in Lesotho in 1996 to that in 1999?
Your answer should be very brief. 1.05. What is the ratio of the Mortality rate(per 1,000 live births) in Senegal in 1996 to that in 1999?
Ensure brevity in your answer.  1.02. What is the ratio of the Mortality rate(per 1,000 live births) of Timor-Leste in 1996 to that in 1999?
Give a very brief answer. 1.14. What is the ratio of the Mortality rate(per 1,000 live births) of Lesotho in 1997 to that in 1998?
Offer a very short reply. 1.02. What is the ratio of the Mortality rate(per 1,000 live births) of Timor-Leste in 1997 to that in 1998?
Your answer should be compact. 1.05. What is the ratio of the Mortality rate(per 1,000 live births) in Guyana in 1997 to that in 1999?
Your answer should be very brief. 1.05. What is the ratio of the Mortality rate(per 1,000 live births) of Lesotho in 1997 to that in 1999?
Your response must be concise. 1.04. What is the ratio of the Mortality rate(per 1,000 live births) of Senegal in 1997 to that in 1999?
Provide a succinct answer. 1.02. What is the ratio of the Mortality rate(per 1,000 live births) of Timor-Leste in 1997 to that in 1999?
Provide a succinct answer. 1.09. What is the ratio of the Mortality rate(per 1,000 live births) in Guyana in 1998 to that in 1999?
Offer a very short reply. 1.03. What is the ratio of the Mortality rate(per 1,000 live births) in Lesotho in 1998 to that in 1999?
Give a very brief answer. 1.02. What is the ratio of the Mortality rate(per 1,000 live births) in Senegal in 1998 to that in 1999?
Give a very brief answer. 1.01. What is the ratio of the Mortality rate(per 1,000 live births) in Timor-Leste in 1998 to that in 1999?
Ensure brevity in your answer.  1.05. What is the difference between the highest and the second highest Mortality rate(per 1,000 live births) of Guyana?
Your answer should be very brief. 0.3. What is the difference between the highest and the second highest Mortality rate(per 1,000 live births) of Lesotho?
Your answer should be compact. 0. What is the difference between the highest and the second highest Mortality rate(per 1,000 live births) of Timor-Leste?
Offer a terse response. 1.9. What is the difference between the highest and the lowest Mortality rate(per 1,000 live births) in Guyana?
Keep it short and to the point. 3.2. What is the difference between the highest and the lowest Mortality rate(per 1,000 live births) of Lesotho?
Make the answer very short. 2.3. 